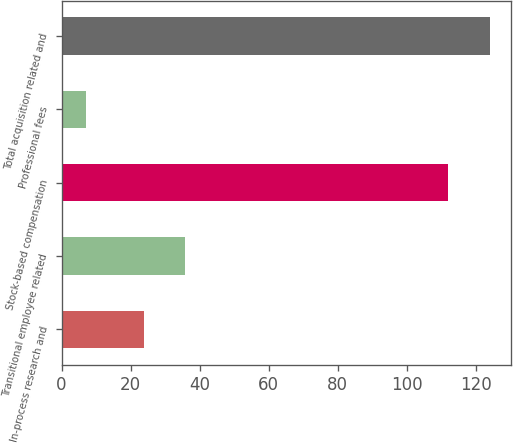<chart> <loc_0><loc_0><loc_500><loc_500><bar_chart><fcel>In-process research and<fcel>Transitional employee related<fcel>Stock-based compensation<fcel>Professional fees<fcel>Total acquisition related and<nl><fcel>24<fcel>35.7<fcel>112<fcel>7<fcel>124<nl></chart> 